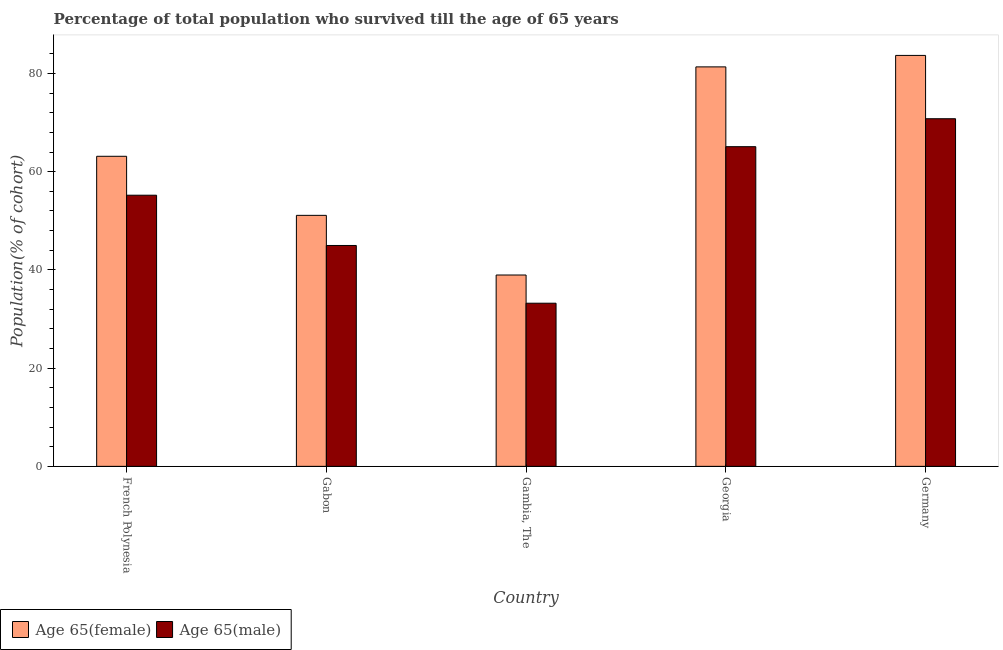Are the number of bars per tick equal to the number of legend labels?
Offer a terse response. Yes. How many bars are there on the 5th tick from the left?
Your response must be concise. 2. What is the label of the 4th group of bars from the left?
Provide a succinct answer. Georgia. In how many cases, is the number of bars for a given country not equal to the number of legend labels?
Provide a short and direct response. 0. What is the percentage of female population who survived till age of 65 in Georgia?
Offer a terse response. 81.34. Across all countries, what is the maximum percentage of female population who survived till age of 65?
Your response must be concise. 83.67. Across all countries, what is the minimum percentage of male population who survived till age of 65?
Your response must be concise. 33.22. In which country was the percentage of male population who survived till age of 65 minimum?
Keep it short and to the point. Gambia, The. What is the total percentage of female population who survived till age of 65 in the graph?
Offer a very short reply. 318.22. What is the difference between the percentage of male population who survived till age of 65 in Georgia and that in Germany?
Make the answer very short. -5.69. What is the difference between the percentage of male population who survived till age of 65 in French Polynesia and the percentage of female population who survived till age of 65 in Germany?
Ensure brevity in your answer.  -28.47. What is the average percentage of female population who survived till age of 65 per country?
Give a very brief answer. 63.64. What is the difference between the percentage of male population who survived till age of 65 and percentage of female population who survived till age of 65 in Gambia, The?
Provide a succinct answer. -5.74. What is the ratio of the percentage of male population who survived till age of 65 in Georgia to that in Germany?
Your answer should be very brief. 0.92. Is the percentage of male population who survived till age of 65 in French Polynesia less than that in Germany?
Give a very brief answer. Yes. Is the difference between the percentage of male population who survived till age of 65 in Gambia, The and Germany greater than the difference between the percentage of female population who survived till age of 65 in Gambia, The and Germany?
Offer a terse response. Yes. What is the difference between the highest and the second highest percentage of male population who survived till age of 65?
Offer a very short reply. 5.69. What is the difference between the highest and the lowest percentage of female population who survived till age of 65?
Your answer should be compact. 44.71. In how many countries, is the percentage of male population who survived till age of 65 greater than the average percentage of male population who survived till age of 65 taken over all countries?
Keep it short and to the point. 3. Is the sum of the percentage of male population who survived till age of 65 in French Polynesia and Gabon greater than the maximum percentage of female population who survived till age of 65 across all countries?
Offer a terse response. Yes. What does the 1st bar from the left in Gabon represents?
Keep it short and to the point. Age 65(female). What does the 2nd bar from the right in Georgia represents?
Your response must be concise. Age 65(female). How many bars are there?
Keep it short and to the point. 10. Are all the bars in the graph horizontal?
Your answer should be very brief. No. How many countries are there in the graph?
Give a very brief answer. 5. Are the values on the major ticks of Y-axis written in scientific E-notation?
Offer a very short reply. No. Does the graph contain any zero values?
Provide a succinct answer. No. Where does the legend appear in the graph?
Ensure brevity in your answer.  Bottom left. How many legend labels are there?
Ensure brevity in your answer.  2. How are the legend labels stacked?
Offer a very short reply. Horizontal. What is the title of the graph?
Your response must be concise. Percentage of total population who survived till the age of 65 years. What is the label or title of the Y-axis?
Your answer should be very brief. Population(% of cohort). What is the Population(% of cohort) of Age 65(female) in French Polynesia?
Offer a very short reply. 63.14. What is the Population(% of cohort) in Age 65(male) in French Polynesia?
Ensure brevity in your answer.  55.21. What is the Population(% of cohort) of Age 65(female) in Gabon?
Offer a very short reply. 51.11. What is the Population(% of cohort) in Age 65(male) in Gabon?
Provide a short and direct response. 44.98. What is the Population(% of cohort) of Age 65(female) in Gambia, The?
Ensure brevity in your answer.  38.96. What is the Population(% of cohort) in Age 65(male) in Gambia, The?
Provide a succinct answer. 33.22. What is the Population(% of cohort) in Age 65(female) in Georgia?
Give a very brief answer. 81.34. What is the Population(% of cohort) in Age 65(male) in Georgia?
Make the answer very short. 65.09. What is the Population(% of cohort) of Age 65(female) in Germany?
Keep it short and to the point. 83.67. What is the Population(% of cohort) in Age 65(male) in Germany?
Keep it short and to the point. 70.78. Across all countries, what is the maximum Population(% of cohort) of Age 65(female)?
Provide a succinct answer. 83.67. Across all countries, what is the maximum Population(% of cohort) of Age 65(male)?
Your answer should be compact. 70.78. Across all countries, what is the minimum Population(% of cohort) in Age 65(female)?
Offer a terse response. 38.96. Across all countries, what is the minimum Population(% of cohort) of Age 65(male)?
Your response must be concise. 33.22. What is the total Population(% of cohort) of Age 65(female) in the graph?
Keep it short and to the point. 318.22. What is the total Population(% of cohort) in Age 65(male) in the graph?
Keep it short and to the point. 269.28. What is the difference between the Population(% of cohort) of Age 65(female) in French Polynesia and that in Gabon?
Ensure brevity in your answer.  12.03. What is the difference between the Population(% of cohort) in Age 65(male) in French Polynesia and that in Gabon?
Your answer should be very brief. 10.23. What is the difference between the Population(% of cohort) in Age 65(female) in French Polynesia and that in Gambia, The?
Keep it short and to the point. 24.17. What is the difference between the Population(% of cohort) of Age 65(male) in French Polynesia and that in Gambia, The?
Keep it short and to the point. 21.99. What is the difference between the Population(% of cohort) in Age 65(female) in French Polynesia and that in Georgia?
Give a very brief answer. -18.21. What is the difference between the Population(% of cohort) in Age 65(male) in French Polynesia and that in Georgia?
Your response must be concise. -9.88. What is the difference between the Population(% of cohort) in Age 65(female) in French Polynesia and that in Germany?
Your answer should be very brief. -20.54. What is the difference between the Population(% of cohort) in Age 65(male) in French Polynesia and that in Germany?
Your answer should be compact. -15.57. What is the difference between the Population(% of cohort) in Age 65(female) in Gabon and that in Gambia, The?
Offer a terse response. 12.14. What is the difference between the Population(% of cohort) of Age 65(male) in Gabon and that in Gambia, The?
Make the answer very short. 11.76. What is the difference between the Population(% of cohort) of Age 65(female) in Gabon and that in Georgia?
Your response must be concise. -30.23. What is the difference between the Population(% of cohort) of Age 65(male) in Gabon and that in Georgia?
Your answer should be very brief. -20.12. What is the difference between the Population(% of cohort) in Age 65(female) in Gabon and that in Germany?
Offer a very short reply. -32.57. What is the difference between the Population(% of cohort) in Age 65(male) in Gabon and that in Germany?
Keep it short and to the point. -25.81. What is the difference between the Population(% of cohort) in Age 65(female) in Gambia, The and that in Georgia?
Offer a very short reply. -42.38. What is the difference between the Population(% of cohort) in Age 65(male) in Gambia, The and that in Georgia?
Your answer should be compact. -31.87. What is the difference between the Population(% of cohort) of Age 65(female) in Gambia, The and that in Germany?
Offer a very short reply. -44.71. What is the difference between the Population(% of cohort) in Age 65(male) in Gambia, The and that in Germany?
Ensure brevity in your answer.  -37.56. What is the difference between the Population(% of cohort) in Age 65(female) in Georgia and that in Germany?
Make the answer very short. -2.33. What is the difference between the Population(% of cohort) in Age 65(male) in Georgia and that in Germany?
Your response must be concise. -5.69. What is the difference between the Population(% of cohort) of Age 65(female) in French Polynesia and the Population(% of cohort) of Age 65(male) in Gabon?
Ensure brevity in your answer.  18.16. What is the difference between the Population(% of cohort) in Age 65(female) in French Polynesia and the Population(% of cohort) in Age 65(male) in Gambia, The?
Your answer should be very brief. 29.92. What is the difference between the Population(% of cohort) in Age 65(female) in French Polynesia and the Population(% of cohort) in Age 65(male) in Georgia?
Make the answer very short. -1.96. What is the difference between the Population(% of cohort) of Age 65(female) in French Polynesia and the Population(% of cohort) of Age 65(male) in Germany?
Ensure brevity in your answer.  -7.65. What is the difference between the Population(% of cohort) in Age 65(female) in Gabon and the Population(% of cohort) in Age 65(male) in Gambia, The?
Your answer should be very brief. 17.89. What is the difference between the Population(% of cohort) of Age 65(female) in Gabon and the Population(% of cohort) of Age 65(male) in Georgia?
Your answer should be very brief. -13.98. What is the difference between the Population(% of cohort) in Age 65(female) in Gabon and the Population(% of cohort) in Age 65(male) in Germany?
Offer a terse response. -19.68. What is the difference between the Population(% of cohort) of Age 65(female) in Gambia, The and the Population(% of cohort) of Age 65(male) in Georgia?
Provide a short and direct response. -26.13. What is the difference between the Population(% of cohort) of Age 65(female) in Gambia, The and the Population(% of cohort) of Age 65(male) in Germany?
Give a very brief answer. -31.82. What is the difference between the Population(% of cohort) of Age 65(female) in Georgia and the Population(% of cohort) of Age 65(male) in Germany?
Offer a terse response. 10.56. What is the average Population(% of cohort) of Age 65(female) per country?
Your response must be concise. 63.64. What is the average Population(% of cohort) in Age 65(male) per country?
Your answer should be very brief. 53.86. What is the difference between the Population(% of cohort) of Age 65(female) and Population(% of cohort) of Age 65(male) in French Polynesia?
Your answer should be compact. 7.93. What is the difference between the Population(% of cohort) of Age 65(female) and Population(% of cohort) of Age 65(male) in Gabon?
Give a very brief answer. 6.13. What is the difference between the Population(% of cohort) in Age 65(female) and Population(% of cohort) in Age 65(male) in Gambia, The?
Give a very brief answer. 5.74. What is the difference between the Population(% of cohort) of Age 65(female) and Population(% of cohort) of Age 65(male) in Georgia?
Your answer should be very brief. 16.25. What is the difference between the Population(% of cohort) of Age 65(female) and Population(% of cohort) of Age 65(male) in Germany?
Provide a short and direct response. 12.89. What is the ratio of the Population(% of cohort) in Age 65(female) in French Polynesia to that in Gabon?
Ensure brevity in your answer.  1.24. What is the ratio of the Population(% of cohort) of Age 65(male) in French Polynesia to that in Gabon?
Offer a terse response. 1.23. What is the ratio of the Population(% of cohort) in Age 65(female) in French Polynesia to that in Gambia, The?
Provide a short and direct response. 1.62. What is the ratio of the Population(% of cohort) in Age 65(male) in French Polynesia to that in Gambia, The?
Your answer should be very brief. 1.66. What is the ratio of the Population(% of cohort) in Age 65(female) in French Polynesia to that in Georgia?
Make the answer very short. 0.78. What is the ratio of the Population(% of cohort) in Age 65(male) in French Polynesia to that in Georgia?
Your response must be concise. 0.85. What is the ratio of the Population(% of cohort) of Age 65(female) in French Polynesia to that in Germany?
Your answer should be compact. 0.75. What is the ratio of the Population(% of cohort) of Age 65(male) in French Polynesia to that in Germany?
Keep it short and to the point. 0.78. What is the ratio of the Population(% of cohort) in Age 65(female) in Gabon to that in Gambia, The?
Provide a succinct answer. 1.31. What is the ratio of the Population(% of cohort) of Age 65(male) in Gabon to that in Gambia, The?
Give a very brief answer. 1.35. What is the ratio of the Population(% of cohort) in Age 65(female) in Gabon to that in Georgia?
Offer a very short reply. 0.63. What is the ratio of the Population(% of cohort) of Age 65(male) in Gabon to that in Georgia?
Offer a very short reply. 0.69. What is the ratio of the Population(% of cohort) of Age 65(female) in Gabon to that in Germany?
Provide a short and direct response. 0.61. What is the ratio of the Population(% of cohort) of Age 65(male) in Gabon to that in Germany?
Your response must be concise. 0.64. What is the ratio of the Population(% of cohort) in Age 65(female) in Gambia, The to that in Georgia?
Keep it short and to the point. 0.48. What is the ratio of the Population(% of cohort) in Age 65(male) in Gambia, The to that in Georgia?
Your answer should be very brief. 0.51. What is the ratio of the Population(% of cohort) of Age 65(female) in Gambia, The to that in Germany?
Provide a short and direct response. 0.47. What is the ratio of the Population(% of cohort) of Age 65(male) in Gambia, The to that in Germany?
Your response must be concise. 0.47. What is the ratio of the Population(% of cohort) of Age 65(female) in Georgia to that in Germany?
Offer a very short reply. 0.97. What is the ratio of the Population(% of cohort) of Age 65(male) in Georgia to that in Germany?
Ensure brevity in your answer.  0.92. What is the difference between the highest and the second highest Population(% of cohort) of Age 65(female)?
Give a very brief answer. 2.33. What is the difference between the highest and the second highest Population(% of cohort) in Age 65(male)?
Provide a short and direct response. 5.69. What is the difference between the highest and the lowest Population(% of cohort) in Age 65(female)?
Your answer should be compact. 44.71. What is the difference between the highest and the lowest Population(% of cohort) of Age 65(male)?
Your response must be concise. 37.56. 